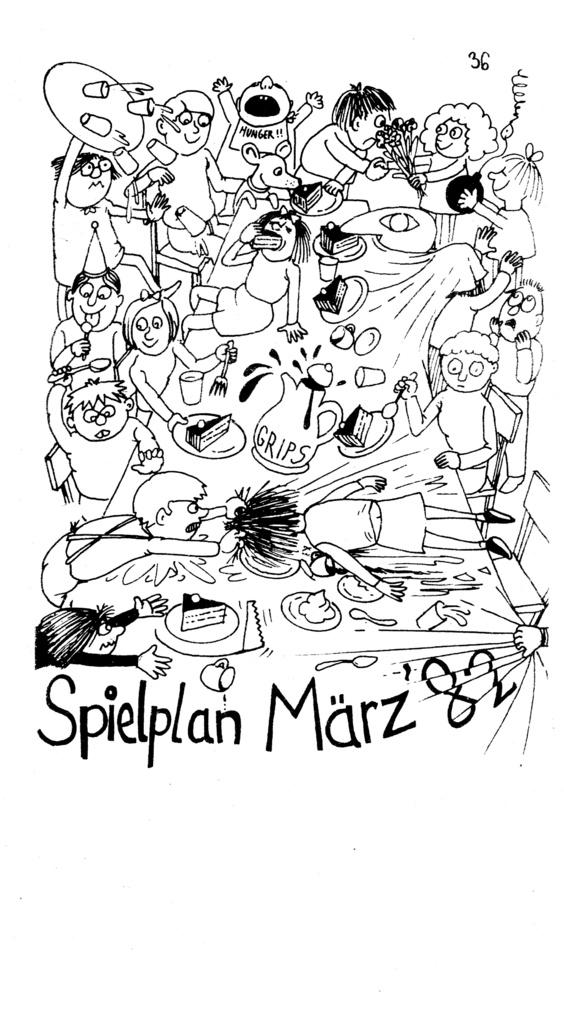What is present in the image that contains images and text? There is a poster in the image that contains images of people and text. Can you describe the images on the poster? The images on the poster contain pictures of people. What else can be found on the poster besides the images? There is text on the poster. What type of hat is the person wearing in the image? There is no person wearing a hat in the image; the poster contains images of people, but no specific person or hat is visible. 